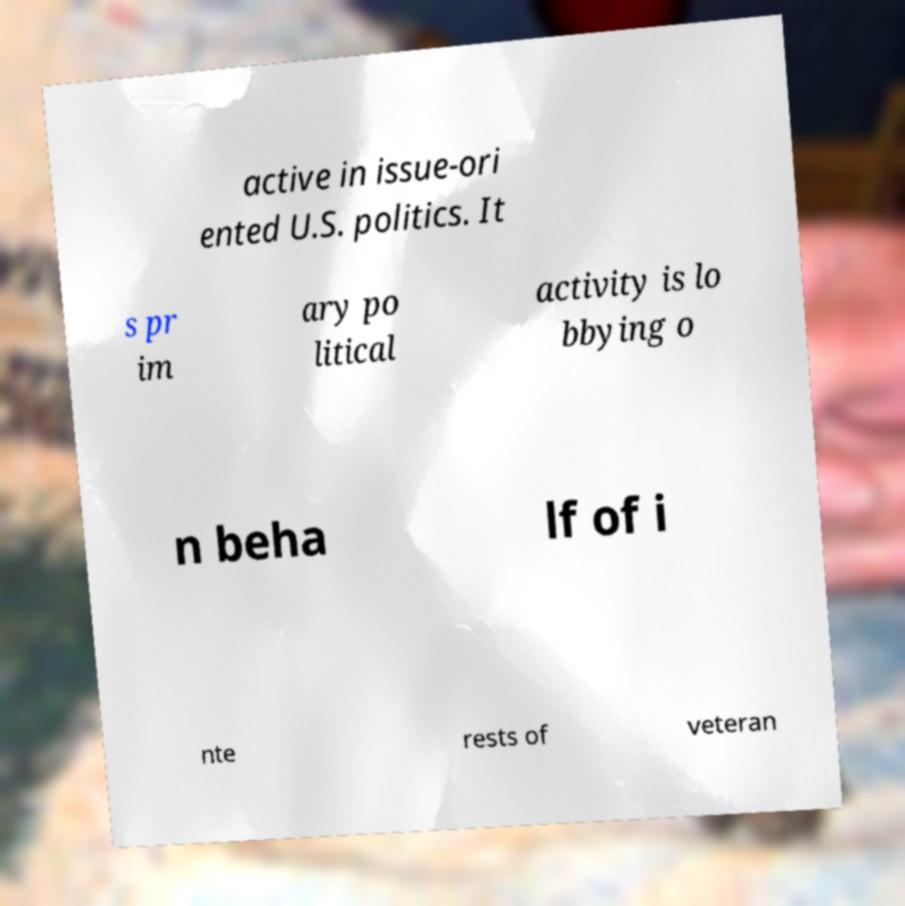Please identify and transcribe the text found in this image. active in issue-ori ented U.S. politics. It s pr im ary po litical activity is lo bbying o n beha lf of i nte rests of veteran 